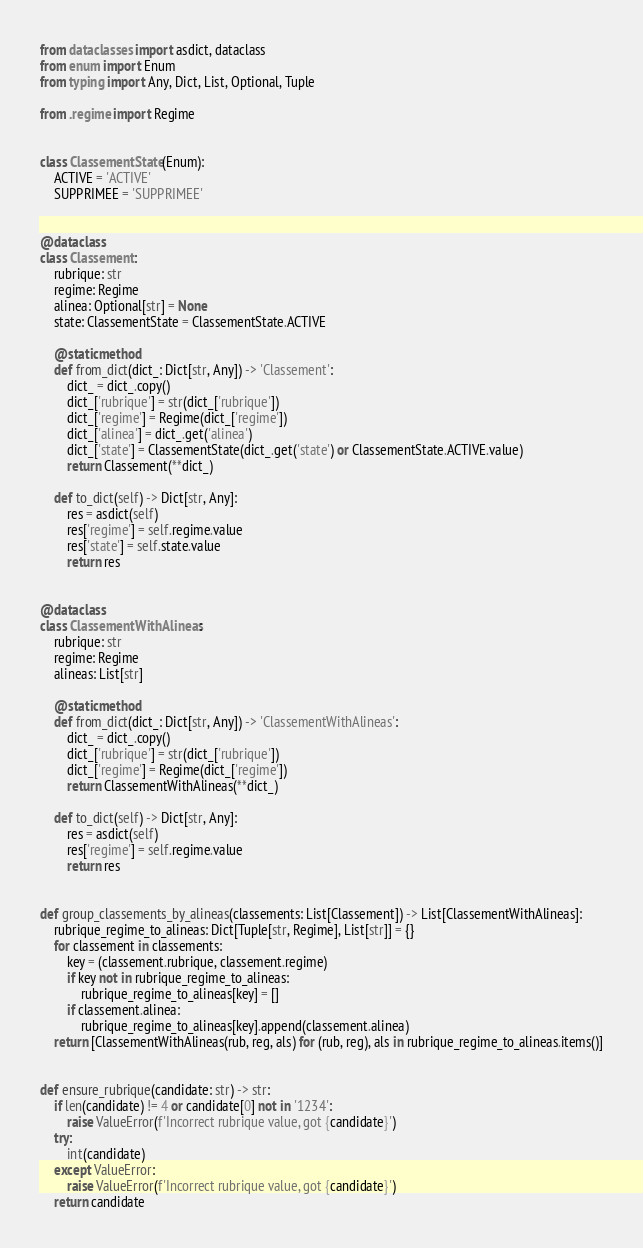<code> <loc_0><loc_0><loc_500><loc_500><_Python_>from dataclasses import asdict, dataclass
from enum import Enum
from typing import Any, Dict, List, Optional, Tuple

from .regime import Regime


class ClassementState(Enum):
    ACTIVE = 'ACTIVE'
    SUPPRIMEE = 'SUPPRIMEE'


@dataclass
class Classement:
    rubrique: str
    regime: Regime
    alinea: Optional[str] = None
    state: ClassementState = ClassementState.ACTIVE

    @staticmethod
    def from_dict(dict_: Dict[str, Any]) -> 'Classement':
        dict_ = dict_.copy()
        dict_['rubrique'] = str(dict_['rubrique'])
        dict_['regime'] = Regime(dict_['regime'])
        dict_['alinea'] = dict_.get('alinea')
        dict_['state'] = ClassementState(dict_.get('state') or ClassementState.ACTIVE.value)
        return Classement(**dict_)

    def to_dict(self) -> Dict[str, Any]:
        res = asdict(self)
        res['regime'] = self.regime.value
        res['state'] = self.state.value
        return res


@dataclass
class ClassementWithAlineas:
    rubrique: str
    regime: Regime
    alineas: List[str]

    @staticmethod
    def from_dict(dict_: Dict[str, Any]) -> 'ClassementWithAlineas':
        dict_ = dict_.copy()
        dict_['rubrique'] = str(dict_['rubrique'])
        dict_['regime'] = Regime(dict_['regime'])
        return ClassementWithAlineas(**dict_)

    def to_dict(self) -> Dict[str, Any]:
        res = asdict(self)
        res['regime'] = self.regime.value
        return res


def group_classements_by_alineas(classements: List[Classement]) -> List[ClassementWithAlineas]:
    rubrique_regime_to_alineas: Dict[Tuple[str, Regime], List[str]] = {}
    for classement in classements:
        key = (classement.rubrique, classement.regime)
        if key not in rubrique_regime_to_alineas:
            rubrique_regime_to_alineas[key] = []
        if classement.alinea:
            rubrique_regime_to_alineas[key].append(classement.alinea)
    return [ClassementWithAlineas(rub, reg, als) for (rub, reg), als in rubrique_regime_to_alineas.items()]


def ensure_rubrique(candidate: str) -> str:
    if len(candidate) != 4 or candidate[0] not in '1234':
        raise ValueError(f'Incorrect rubrique value, got {candidate}')
    try:
        int(candidate)
    except ValueError:
        raise ValueError(f'Incorrect rubrique value, got {candidate}')
    return candidate
</code> 